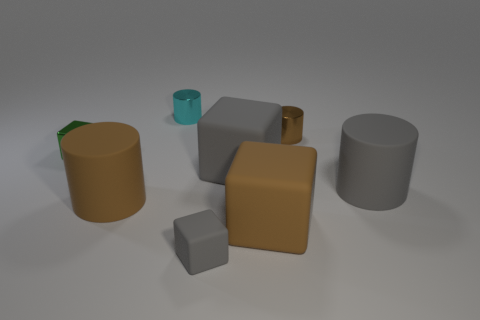What colors are the objects in the image, aside from the cyan one? Aside from the cyan object, there are objects in shades of brown, gray, and a metallic gold-like color.  Do the shapes have a particular arrangement or pattern? The arrangement appears somewhat random, with no clear pattern emerging. They are spread out across the surface, each object standing separate from the others. 